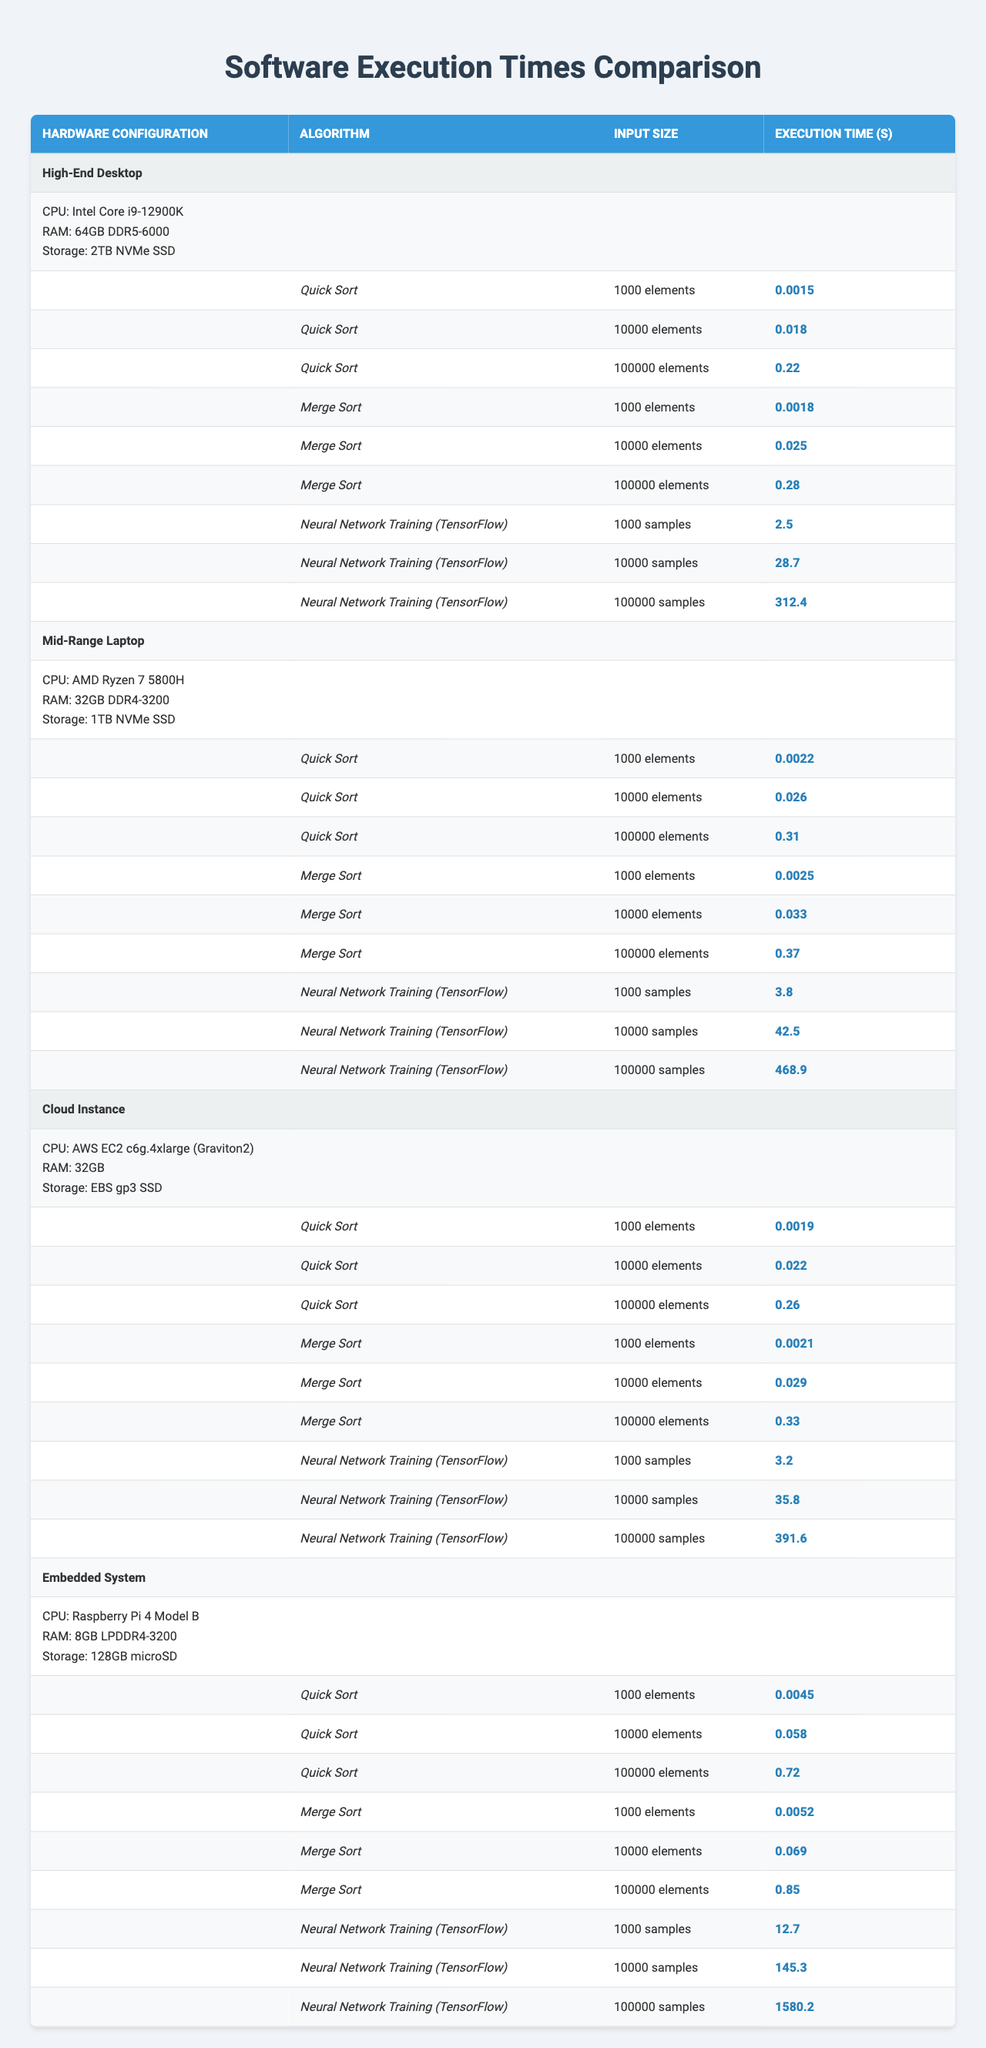What is the execution time of Quick Sort on the High-End Desktop for 10,000 elements? The table indicates that the execution time of Quick Sort on a High-End Desktop for 10,000 elements is 0.018 seconds.
Answer: 0.018 seconds Which algorithm takes the longest time for 100,000 elements on the Mid-Range Laptop? By examining the table, for 100,000 elements, Merge Sort on the Mid-Range Laptop takes the longest time, which is 0.37 seconds, compared to Quick Sort (0.31 seconds) and Neural Network Training (468.9 seconds).
Answer: Merge Sort What is the difference in execution time between Neural Network Training with 10,000 samples on the High-End Desktop and the Cloud Instance? The execution time for Neural Network Training with 10,000 samples on the High-End Desktop is 28.7 seconds and on the Cloud Instance it is 35.8 seconds. The difference is 35.8 - 28.7 = 7.1 seconds.
Answer: 7.1 seconds On the Embedded System, which sorting algorithm is slower for 10,000 elements, Quick Sort or Merge Sort? The execution time for Quick Sort is 0.058 seconds and for Merge Sort is 0.069 seconds on the Embedded System for 10,000 elements. Merge Sort is slower since 0.069 > 0.058.
Answer: Merge Sort What is the average execution time of Quick Sort across all hardware configurations for 100,000 elements? The execution times for Quick Sort on different hardware configurations are: High-End Desktop (0.22), Mid-Range Laptop (0.31), Cloud Instance (0.26), and Embedded System (0.72). Summing these gives 0.22 + 0.31 + 0.26 + 0.72 = 1.51 seconds. Dividing this sum by 4, the number of configurations, gives an average of 1.51 / 4 = 0.3775 seconds.
Answer: 0.3775 seconds Is it true that Neural Network Training on the Embedded System takes longer than any algorithm on the High-End Desktop? The max execution time for any algorithm on the High-End Desktop is 312.4 seconds (Neural Network Training for 100,000 samples). When comparing that to Neural Network Training on the Embedded System, which is 1580.2 seconds, it confirms that it is indeed true.
Answer: Yes What is the maximum execution time across all algorithms for 10,000 elements on the Mid-Range Laptop? Looking at the Mid-Range Laptop for 10,000 elements, the times are: Quick Sort (0.026), Merge Sort (0.033), and Neural Network Training (42.5 seconds). Among these, the maximum is for Neural Network Training at 42.5 seconds.
Answer: 42.5 seconds Which hardware configuration has the fastest execution time for Merge Sort with 1,000 elements? By checking the execution times for Merge Sort with 1,000 elements across hardware configurations, the times are: High-End Desktop (0.0018 seconds), Mid-Range Laptop (0.0025 seconds), Cloud Instance (0.0021 seconds), and Embedded System (0.0052 seconds). The High-End Desktop has the fastest execution time at 0.0018 seconds.
Answer: High-End Desktop 